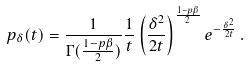Convert formula to latex. <formula><loc_0><loc_0><loc_500><loc_500>p _ { \delta } ( t ) = \frac { 1 } { \Gamma ( \frac { 1 - p \beta } { 2 } ) } \frac { 1 } { t } \left ( \frac { \delta ^ { 2 } } { 2 t } \right ) ^ { \frac { 1 - p \beta } { 2 } } e ^ { - \frac { \delta ^ { 2 } } { 2 t } } \, .</formula> 